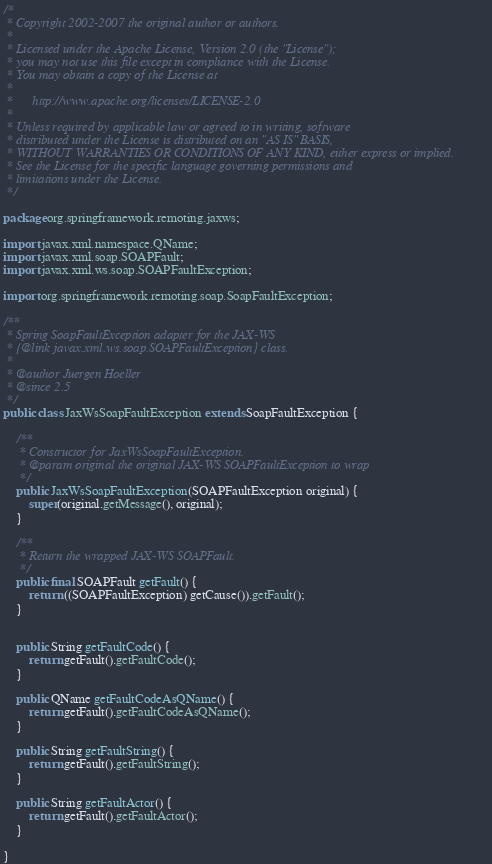Convert code to text. <code><loc_0><loc_0><loc_500><loc_500><_Java_>/*
 * Copyright 2002-2007 the original author or authors.
 *
 * Licensed under the Apache License, Version 2.0 (the "License");
 * you may not use this file except in compliance with the License.
 * You may obtain a copy of the License at
 *
 *      http://www.apache.org/licenses/LICENSE-2.0
 *
 * Unless required by applicable law or agreed to in writing, software
 * distributed under the License is distributed on an "AS IS" BASIS,
 * WITHOUT WARRANTIES OR CONDITIONS OF ANY KIND, either express or implied.
 * See the License for the specific language governing permissions and
 * limitations under the License.
 */

package org.springframework.remoting.jaxws;

import javax.xml.namespace.QName;
import javax.xml.soap.SOAPFault;
import javax.xml.ws.soap.SOAPFaultException;

import org.springframework.remoting.soap.SoapFaultException;

/**
 * Spring SoapFaultException adapter for the JAX-WS
 * {@link javax.xml.ws.soap.SOAPFaultException} class.
 *
 * @author Juergen Hoeller
 * @since 2.5
 */
public class JaxWsSoapFaultException extends SoapFaultException {

	/**
	 * Constructor for JaxWsSoapFaultException.
	 * @param original the original JAX-WS SOAPFaultException to wrap
	 */
	public JaxWsSoapFaultException(SOAPFaultException original) {
		super(original.getMessage(), original);
	}

	/**
	 * Return the wrapped JAX-WS SOAPFault.
	 */
	public final SOAPFault getFault() {
		return ((SOAPFaultException) getCause()).getFault();
	}


	public String getFaultCode() {
		return getFault().getFaultCode();
	}

	public QName getFaultCodeAsQName() {
		return getFault().getFaultCodeAsQName();
	}

	public String getFaultString() {
		return getFault().getFaultString();
	}

	public String getFaultActor() {
		return getFault().getFaultActor();
	}

}
</code> 